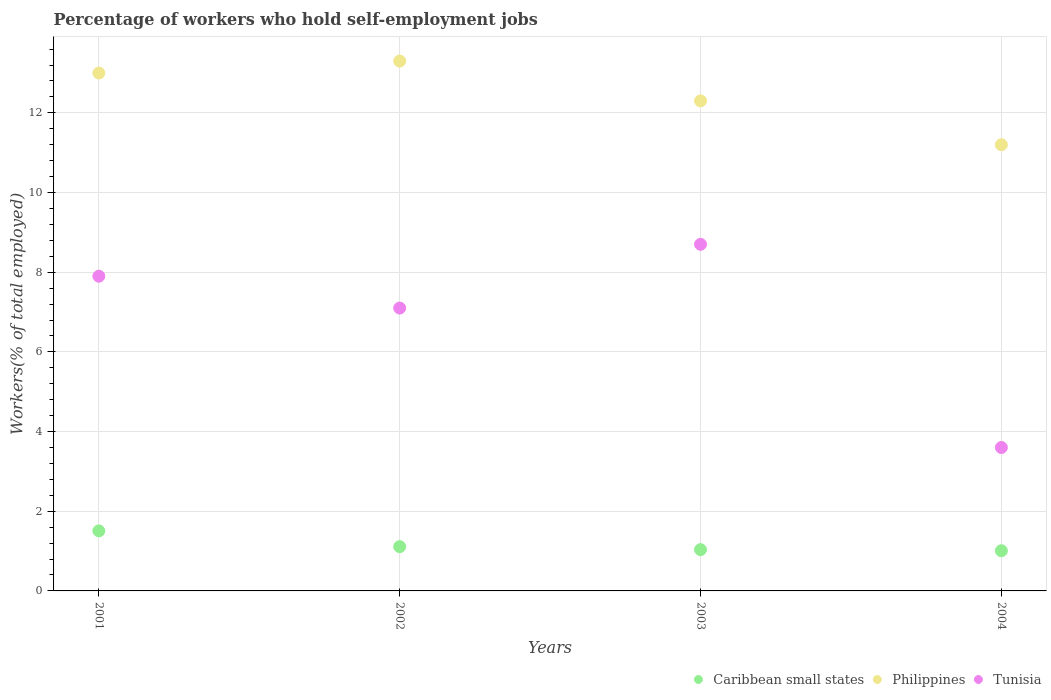How many different coloured dotlines are there?
Offer a very short reply. 3. What is the percentage of self-employed workers in Caribbean small states in 2002?
Give a very brief answer. 1.11. Across all years, what is the maximum percentage of self-employed workers in Tunisia?
Provide a short and direct response. 8.7. Across all years, what is the minimum percentage of self-employed workers in Philippines?
Your response must be concise. 11.2. In which year was the percentage of self-employed workers in Caribbean small states maximum?
Your answer should be very brief. 2001. In which year was the percentage of self-employed workers in Philippines minimum?
Offer a terse response. 2004. What is the total percentage of self-employed workers in Caribbean small states in the graph?
Your answer should be very brief. 4.66. What is the difference between the percentage of self-employed workers in Tunisia in 2002 and that in 2003?
Your answer should be very brief. -1.6. What is the difference between the percentage of self-employed workers in Tunisia in 2002 and the percentage of self-employed workers in Caribbean small states in 2001?
Offer a very short reply. 5.59. What is the average percentage of self-employed workers in Tunisia per year?
Keep it short and to the point. 6.82. In the year 2004, what is the difference between the percentage of self-employed workers in Caribbean small states and percentage of self-employed workers in Tunisia?
Provide a short and direct response. -2.59. In how many years, is the percentage of self-employed workers in Tunisia greater than 0.8 %?
Ensure brevity in your answer.  4. What is the ratio of the percentage of self-employed workers in Caribbean small states in 2003 to that in 2004?
Offer a terse response. 1.03. Is the difference between the percentage of self-employed workers in Caribbean small states in 2001 and 2002 greater than the difference between the percentage of self-employed workers in Tunisia in 2001 and 2002?
Keep it short and to the point. No. What is the difference between the highest and the second highest percentage of self-employed workers in Tunisia?
Ensure brevity in your answer.  0.8. What is the difference between the highest and the lowest percentage of self-employed workers in Philippines?
Ensure brevity in your answer.  2.1. In how many years, is the percentage of self-employed workers in Philippines greater than the average percentage of self-employed workers in Philippines taken over all years?
Make the answer very short. 2. Is the sum of the percentage of self-employed workers in Tunisia in 2001 and 2003 greater than the maximum percentage of self-employed workers in Philippines across all years?
Make the answer very short. Yes. Is the percentage of self-employed workers in Tunisia strictly greater than the percentage of self-employed workers in Philippines over the years?
Give a very brief answer. No. How many years are there in the graph?
Offer a very short reply. 4. Are the values on the major ticks of Y-axis written in scientific E-notation?
Ensure brevity in your answer.  No. Does the graph contain any zero values?
Make the answer very short. No. Does the graph contain grids?
Make the answer very short. Yes. Where does the legend appear in the graph?
Your answer should be compact. Bottom right. How many legend labels are there?
Make the answer very short. 3. What is the title of the graph?
Give a very brief answer. Percentage of workers who hold self-employment jobs. What is the label or title of the Y-axis?
Your answer should be very brief. Workers(% of total employed). What is the Workers(% of total employed) of Caribbean small states in 2001?
Make the answer very short. 1.51. What is the Workers(% of total employed) of Philippines in 2001?
Ensure brevity in your answer.  13. What is the Workers(% of total employed) of Tunisia in 2001?
Give a very brief answer. 7.9. What is the Workers(% of total employed) in Caribbean small states in 2002?
Offer a terse response. 1.11. What is the Workers(% of total employed) in Philippines in 2002?
Give a very brief answer. 13.3. What is the Workers(% of total employed) of Tunisia in 2002?
Make the answer very short. 7.1. What is the Workers(% of total employed) in Caribbean small states in 2003?
Your response must be concise. 1.04. What is the Workers(% of total employed) of Philippines in 2003?
Offer a very short reply. 12.3. What is the Workers(% of total employed) in Tunisia in 2003?
Make the answer very short. 8.7. What is the Workers(% of total employed) of Caribbean small states in 2004?
Your answer should be very brief. 1.01. What is the Workers(% of total employed) in Philippines in 2004?
Keep it short and to the point. 11.2. What is the Workers(% of total employed) in Tunisia in 2004?
Your answer should be very brief. 3.6. Across all years, what is the maximum Workers(% of total employed) of Caribbean small states?
Offer a very short reply. 1.51. Across all years, what is the maximum Workers(% of total employed) of Philippines?
Your answer should be compact. 13.3. Across all years, what is the maximum Workers(% of total employed) of Tunisia?
Your answer should be compact. 8.7. Across all years, what is the minimum Workers(% of total employed) of Caribbean small states?
Provide a short and direct response. 1.01. Across all years, what is the minimum Workers(% of total employed) of Philippines?
Your response must be concise. 11.2. Across all years, what is the minimum Workers(% of total employed) in Tunisia?
Make the answer very short. 3.6. What is the total Workers(% of total employed) of Caribbean small states in the graph?
Make the answer very short. 4.66. What is the total Workers(% of total employed) in Philippines in the graph?
Your response must be concise. 49.8. What is the total Workers(% of total employed) of Tunisia in the graph?
Make the answer very short. 27.3. What is the difference between the Workers(% of total employed) of Caribbean small states in 2001 and that in 2002?
Your answer should be very brief. 0.4. What is the difference between the Workers(% of total employed) in Philippines in 2001 and that in 2002?
Your answer should be compact. -0.3. What is the difference between the Workers(% of total employed) in Tunisia in 2001 and that in 2002?
Provide a succinct answer. 0.8. What is the difference between the Workers(% of total employed) in Caribbean small states in 2001 and that in 2003?
Keep it short and to the point. 0.47. What is the difference between the Workers(% of total employed) in Philippines in 2001 and that in 2003?
Offer a very short reply. 0.7. What is the difference between the Workers(% of total employed) in Tunisia in 2001 and that in 2003?
Ensure brevity in your answer.  -0.8. What is the difference between the Workers(% of total employed) in Caribbean small states in 2001 and that in 2004?
Your response must be concise. 0.5. What is the difference between the Workers(% of total employed) in Caribbean small states in 2002 and that in 2003?
Ensure brevity in your answer.  0.08. What is the difference between the Workers(% of total employed) in Tunisia in 2002 and that in 2003?
Ensure brevity in your answer.  -1.6. What is the difference between the Workers(% of total employed) of Caribbean small states in 2002 and that in 2004?
Offer a terse response. 0.1. What is the difference between the Workers(% of total employed) in Philippines in 2002 and that in 2004?
Offer a terse response. 2.1. What is the difference between the Workers(% of total employed) of Tunisia in 2002 and that in 2004?
Keep it short and to the point. 3.5. What is the difference between the Workers(% of total employed) of Caribbean small states in 2003 and that in 2004?
Provide a short and direct response. 0.03. What is the difference between the Workers(% of total employed) in Philippines in 2003 and that in 2004?
Your answer should be very brief. 1.1. What is the difference between the Workers(% of total employed) in Tunisia in 2003 and that in 2004?
Provide a short and direct response. 5.1. What is the difference between the Workers(% of total employed) in Caribbean small states in 2001 and the Workers(% of total employed) in Philippines in 2002?
Your answer should be very brief. -11.79. What is the difference between the Workers(% of total employed) of Caribbean small states in 2001 and the Workers(% of total employed) of Tunisia in 2002?
Offer a very short reply. -5.59. What is the difference between the Workers(% of total employed) of Philippines in 2001 and the Workers(% of total employed) of Tunisia in 2002?
Provide a succinct answer. 5.9. What is the difference between the Workers(% of total employed) in Caribbean small states in 2001 and the Workers(% of total employed) in Philippines in 2003?
Offer a very short reply. -10.79. What is the difference between the Workers(% of total employed) of Caribbean small states in 2001 and the Workers(% of total employed) of Tunisia in 2003?
Provide a succinct answer. -7.19. What is the difference between the Workers(% of total employed) of Philippines in 2001 and the Workers(% of total employed) of Tunisia in 2003?
Ensure brevity in your answer.  4.3. What is the difference between the Workers(% of total employed) of Caribbean small states in 2001 and the Workers(% of total employed) of Philippines in 2004?
Your answer should be compact. -9.69. What is the difference between the Workers(% of total employed) in Caribbean small states in 2001 and the Workers(% of total employed) in Tunisia in 2004?
Offer a terse response. -2.09. What is the difference between the Workers(% of total employed) of Caribbean small states in 2002 and the Workers(% of total employed) of Philippines in 2003?
Keep it short and to the point. -11.19. What is the difference between the Workers(% of total employed) in Caribbean small states in 2002 and the Workers(% of total employed) in Tunisia in 2003?
Provide a succinct answer. -7.59. What is the difference between the Workers(% of total employed) of Philippines in 2002 and the Workers(% of total employed) of Tunisia in 2003?
Make the answer very short. 4.6. What is the difference between the Workers(% of total employed) in Caribbean small states in 2002 and the Workers(% of total employed) in Philippines in 2004?
Offer a very short reply. -10.09. What is the difference between the Workers(% of total employed) in Caribbean small states in 2002 and the Workers(% of total employed) in Tunisia in 2004?
Give a very brief answer. -2.49. What is the difference between the Workers(% of total employed) in Philippines in 2002 and the Workers(% of total employed) in Tunisia in 2004?
Give a very brief answer. 9.7. What is the difference between the Workers(% of total employed) in Caribbean small states in 2003 and the Workers(% of total employed) in Philippines in 2004?
Give a very brief answer. -10.16. What is the difference between the Workers(% of total employed) in Caribbean small states in 2003 and the Workers(% of total employed) in Tunisia in 2004?
Keep it short and to the point. -2.56. What is the average Workers(% of total employed) in Caribbean small states per year?
Keep it short and to the point. 1.17. What is the average Workers(% of total employed) of Philippines per year?
Your answer should be very brief. 12.45. What is the average Workers(% of total employed) in Tunisia per year?
Your response must be concise. 6.83. In the year 2001, what is the difference between the Workers(% of total employed) in Caribbean small states and Workers(% of total employed) in Philippines?
Provide a succinct answer. -11.49. In the year 2001, what is the difference between the Workers(% of total employed) of Caribbean small states and Workers(% of total employed) of Tunisia?
Ensure brevity in your answer.  -6.39. In the year 2001, what is the difference between the Workers(% of total employed) of Philippines and Workers(% of total employed) of Tunisia?
Give a very brief answer. 5.1. In the year 2002, what is the difference between the Workers(% of total employed) in Caribbean small states and Workers(% of total employed) in Philippines?
Make the answer very short. -12.19. In the year 2002, what is the difference between the Workers(% of total employed) of Caribbean small states and Workers(% of total employed) of Tunisia?
Make the answer very short. -5.99. In the year 2003, what is the difference between the Workers(% of total employed) of Caribbean small states and Workers(% of total employed) of Philippines?
Keep it short and to the point. -11.26. In the year 2003, what is the difference between the Workers(% of total employed) in Caribbean small states and Workers(% of total employed) in Tunisia?
Your response must be concise. -7.66. In the year 2003, what is the difference between the Workers(% of total employed) in Philippines and Workers(% of total employed) in Tunisia?
Keep it short and to the point. 3.6. In the year 2004, what is the difference between the Workers(% of total employed) of Caribbean small states and Workers(% of total employed) of Philippines?
Keep it short and to the point. -10.19. In the year 2004, what is the difference between the Workers(% of total employed) of Caribbean small states and Workers(% of total employed) of Tunisia?
Offer a very short reply. -2.59. What is the ratio of the Workers(% of total employed) of Caribbean small states in 2001 to that in 2002?
Ensure brevity in your answer.  1.36. What is the ratio of the Workers(% of total employed) in Philippines in 2001 to that in 2002?
Keep it short and to the point. 0.98. What is the ratio of the Workers(% of total employed) in Tunisia in 2001 to that in 2002?
Provide a short and direct response. 1.11. What is the ratio of the Workers(% of total employed) in Caribbean small states in 2001 to that in 2003?
Your answer should be very brief. 1.46. What is the ratio of the Workers(% of total employed) of Philippines in 2001 to that in 2003?
Offer a very short reply. 1.06. What is the ratio of the Workers(% of total employed) in Tunisia in 2001 to that in 2003?
Give a very brief answer. 0.91. What is the ratio of the Workers(% of total employed) of Caribbean small states in 2001 to that in 2004?
Your answer should be very brief. 1.49. What is the ratio of the Workers(% of total employed) in Philippines in 2001 to that in 2004?
Offer a terse response. 1.16. What is the ratio of the Workers(% of total employed) in Tunisia in 2001 to that in 2004?
Provide a short and direct response. 2.19. What is the ratio of the Workers(% of total employed) of Caribbean small states in 2002 to that in 2003?
Your response must be concise. 1.07. What is the ratio of the Workers(% of total employed) of Philippines in 2002 to that in 2003?
Make the answer very short. 1.08. What is the ratio of the Workers(% of total employed) of Tunisia in 2002 to that in 2003?
Provide a short and direct response. 0.82. What is the ratio of the Workers(% of total employed) in Caribbean small states in 2002 to that in 2004?
Ensure brevity in your answer.  1.1. What is the ratio of the Workers(% of total employed) of Philippines in 2002 to that in 2004?
Keep it short and to the point. 1.19. What is the ratio of the Workers(% of total employed) of Tunisia in 2002 to that in 2004?
Make the answer very short. 1.97. What is the ratio of the Workers(% of total employed) in Caribbean small states in 2003 to that in 2004?
Offer a terse response. 1.03. What is the ratio of the Workers(% of total employed) of Philippines in 2003 to that in 2004?
Your answer should be compact. 1.1. What is the ratio of the Workers(% of total employed) of Tunisia in 2003 to that in 2004?
Make the answer very short. 2.42. What is the difference between the highest and the second highest Workers(% of total employed) of Caribbean small states?
Your response must be concise. 0.4. What is the difference between the highest and the second highest Workers(% of total employed) in Philippines?
Provide a short and direct response. 0.3. What is the difference between the highest and the lowest Workers(% of total employed) of Caribbean small states?
Keep it short and to the point. 0.5. 